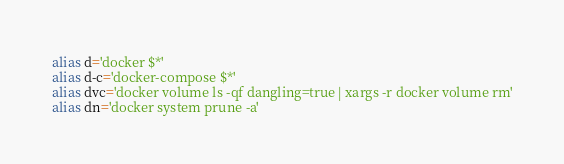<code> <loc_0><loc_0><loc_500><loc_500><_Bash_>alias d='docker $*'
alias d-c='docker-compose $*'
alias dvc='docker volume ls -qf dangling=true | xargs -r docker volume rm'
alias dn='docker system prune -a'
</code> 